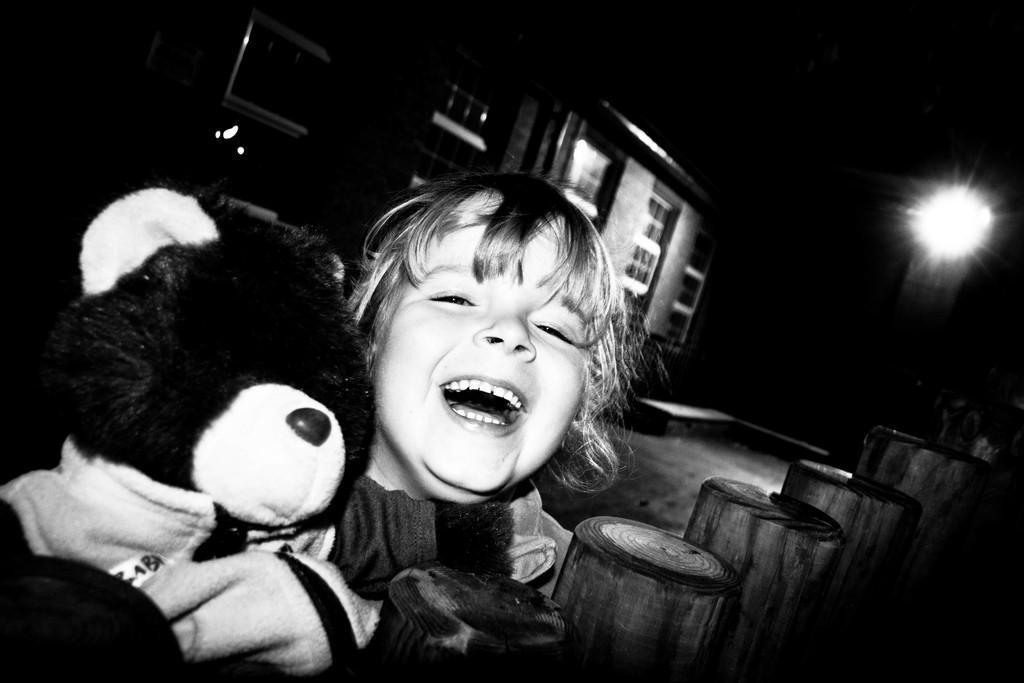How would you summarize this image in a sentence or two? In the picture we can see a child holding a doll and the child is coughing and behind we can see a building with windows and a besides we can see a light. 